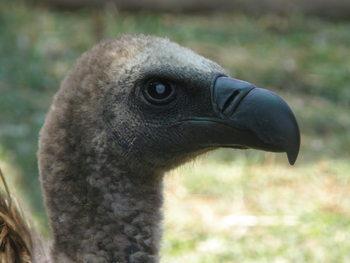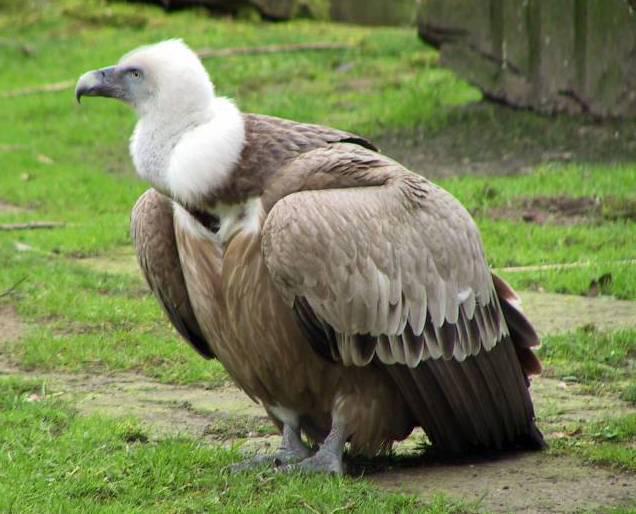The first image is the image on the left, the second image is the image on the right. For the images displayed, is the sentence "The entire bird is visible in the image on the right." factually correct? Answer yes or no. Yes. 